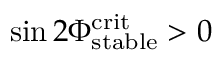Convert formula to latex. <formula><loc_0><loc_0><loc_500><loc_500>\sin 2 \Phi _ { s t a b l e } ^ { c r i t } > 0</formula> 